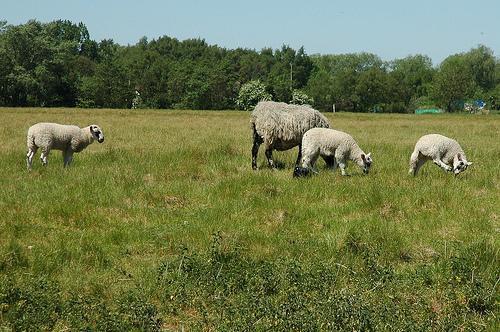How many young sheep are there?
Give a very brief answer. 3. How many sheep are there?
Give a very brief answer. 4. 